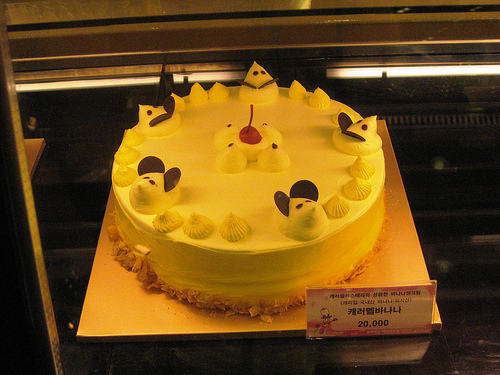<image>
Can you confirm if the mouse is in front of the cherry? Yes. The mouse is positioned in front of the cherry, appearing closer to the camera viewpoint. 